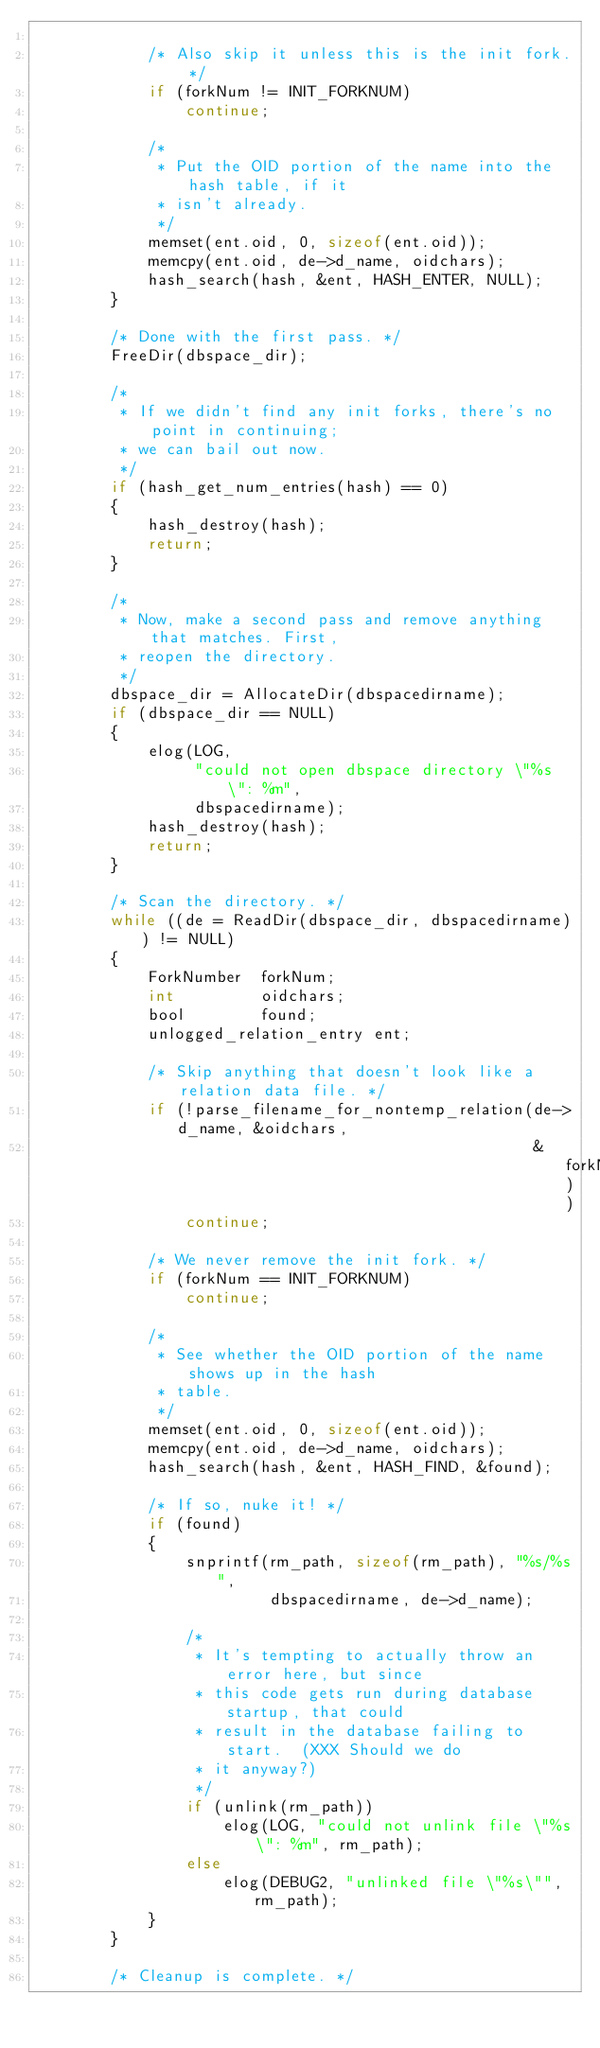<code> <loc_0><loc_0><loc_500><loc_500><_C_>
			/* Also skip it unless this is the init fork. */
			if (forkNum != INIT_FORKNUM)
				continue;

			/*
			 * Put the OID portion of the name into the hash table, if it
			 * isn't already.
			 */
			memset(ent.oid, 0, sizeof(ent.oid));
			memcpy(ent.oid, de->d_name, oidchars);
			hash_search(hash, &ent, HASH_ENTER, NULL);
		}

		/* Done with the first pass. */
		FreeDir(dbspace_dir);

		/*
		 * If we didn't find any init forks, there's no point in continuing;
		 * we can bail out now.
		 */
		if (hash_get_num_entries(hash) == 0)
		{
			hash_destroy(hash);
			return;
		}

		/*
		 * Now, make a second pass and remove anything that matches. First,
		 * reopen the directory.
		 */
		dbspace_dir = AllocateDir(dbspacedirname);
		if (dbspace_dir == NULL)
		{
			elog(LOG,
				 "could not open dbspace directory \"%s\": %m",
				 dbspacedirname);
			hash_destroy(hash);
			return;
		}

		/* Scan the directory. */
		while ((de = ReadDir(dbspace_dir, dbspacedirname)) != NULL)
		{
			ForkNumber	forkNum;
			int			oidchars;
			bool		found;
			unlogged_relation_entry ent;

			/* Skip anything that doesn't look like a relation data file. */
			if (!parse_filename_for_nontemp_relation(de->d_name, &oidchars,
													 &forkNum))
				continue;

			/* We never remove the init fork. */
			if (forkNum == INIT_FORKNUM)
				continue;

			/*
			 * See whether the OID portion of the name shows up in the hash
			 * table.
			 */
			memset(ent.oid, 0, sizeof(ent.oid));
			memcpy(ent.oid, de->d_name, oidchars);
			hash_search(hash, &ent, HASH_FIND, &found);

			/* If so, nuke it! */
			if (found)
			{
				snprintf(rm_path, sizeof(rm_path), "%s/%s",
						 dbspacedirname, de->d_name);

				/*
				 * It's tempting to actually throw an error here, but since
				 * this code gets run during database startup, that could
				 * result in the database failing to start.  (XXX Should we do
				 * it anyway?)
				 */
				if (unlink(rm_path))
					elog(LOG, "could not unlink file \"%s\": %m", rm_path);
				else
					elog(DEBUG2, "unlinked file \"%s\"", rm_path);
			}
		}

		/* Cleanup is complete. */</code> 